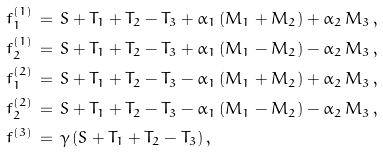<formula> <loc_0><loc_0><loc_500><loc_500>& f ^ { ( 1 ) } _ { 1 } \, = \, S + T _ { 1 } + T _ { 2 } - T _ { 3 } + \alpha _ { 1 } \, ( M _ { 1 } + M _ { 2 } ) + \alpha _ { 2 } \, M _ { 3 } \, , \\ & f ^ { ( 1 ) } _ { 2 } \, = \, S + T _ { 1 } + T _ { 2 } - T _ { 3 } + \alpha _ { 1 } \, ( M _ { 1 } - M _ { 2 } ) - \alpha _ { 2 } \, M _ { 3 } \, , \\ & f ^ { ( 2 ) } _ { 1 } \, = \, S + T _ { 1 } + T _ { 2 } - T _ { 3 } - \alpha _ { 1 } \, ( M _ { 1 } + M _ { 2 } ) + \alpha _ { 2 } \, M _ { 3 } \, , \\ & f ^ { ( 2 ) } _ { 2 } \, = \, S + T _ { 1 } + T _ { 2 } - T _ { 3 } - \alpha _ { 1 } \, ( M _ { 1 } - M _ { 2 } ) - \alpha _ { 2 } \, M _ { 3 } \, , \\ & f ^ { ( 3 ) } \, = \, \gamma \, ( S + T _ { 1 } + T _ { 2 } - T _ { 3 } ) \, , \\</formula> 